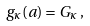<formula> <loc_0><loc_0><loc_500><loc_500>g _ { \kappa } ( { a } ) = G _ { \kappa } \, ,</formula> 